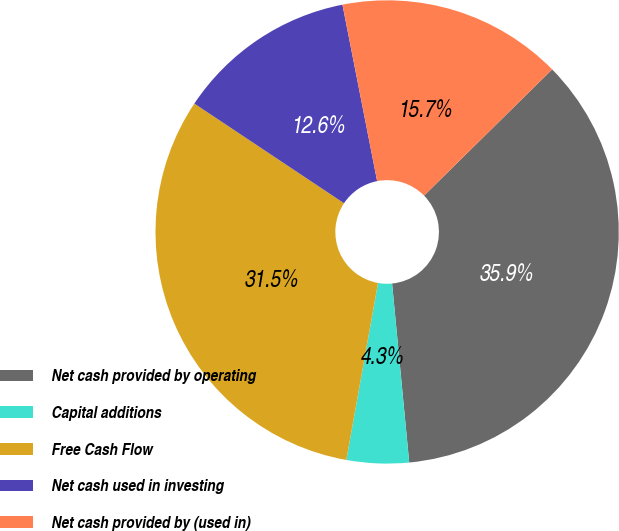Convert chart to OTSL. <chart><loc_0><loc_0><loc_500><loc_500><pie_chart><fcel>Net cash provided by operating<fcel>Capital additions<fcel>Free Cash Flow<fcel>Net cash used in investing<fcel>Net cash provided by (used in)<nl><fcel>35.86%<fcel>4.34%<fcel>31.53%<fcel>12.56%<fcel>15.71%<nl></chart> 